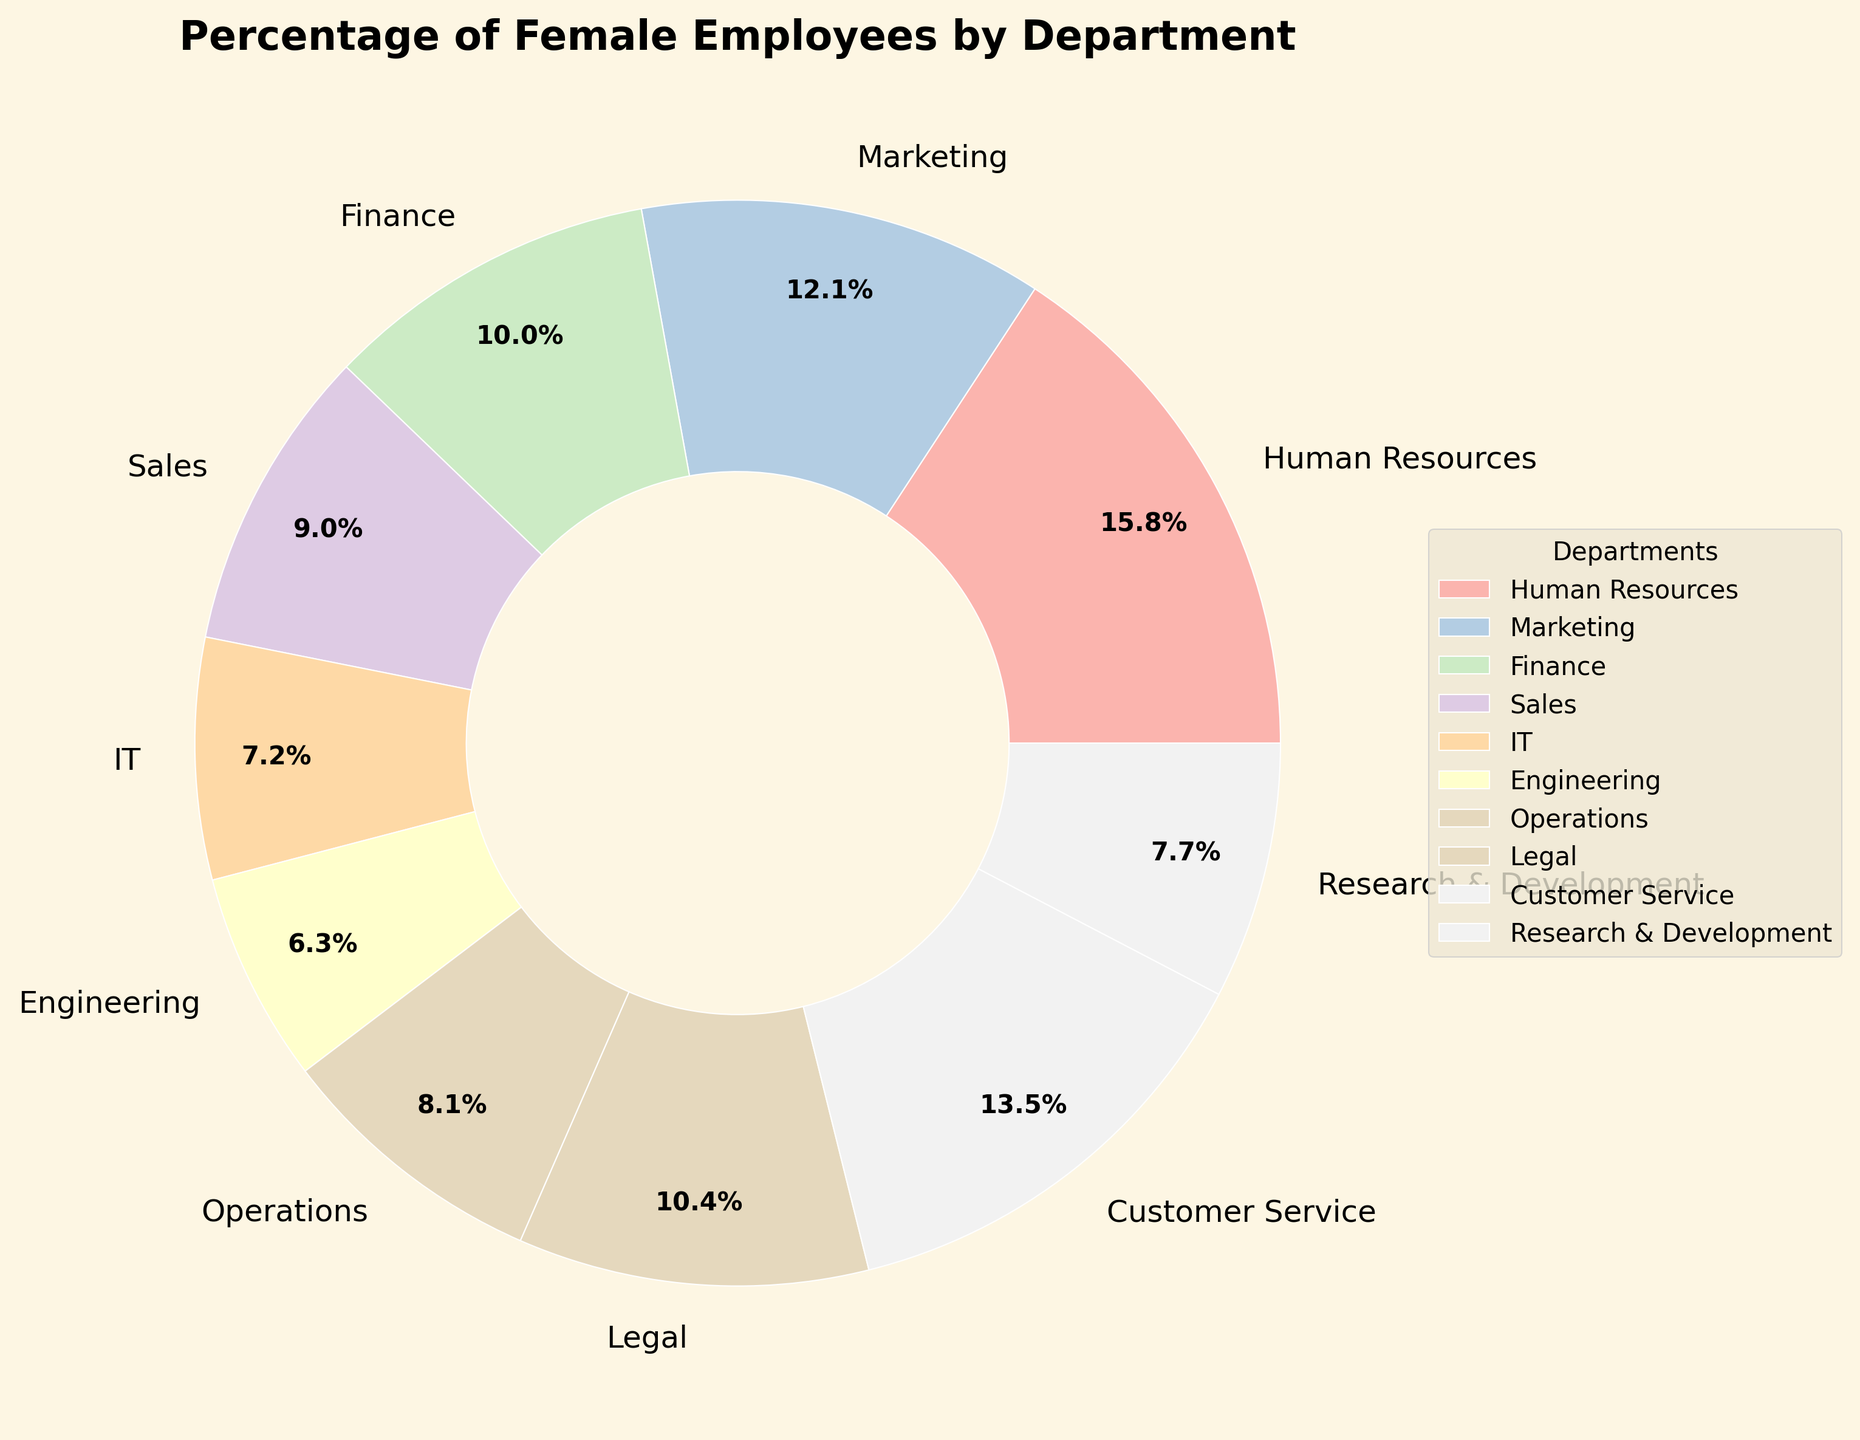Which department has the highest percentage of female employees? The department with the highest percentage of female employees is identified by finding the largest value on the pie chart.
Answer: Human Resources What is the combined percentage of female employees in IT and Sales? To find the combined percentage, sum the percentages of females in IT (31%) and Sales (39%). Therefore, 31% + 39% = 70%.
Answer: 70% How does the percentage of female employees in Marketing compare to that in Engineering? Compare the percentages directly: Marketing has 52% and Engineering has 27%. Marketing has a higher percentage than Engineering.
Answer: Marketing has a higher percentage What is the average percentage of female employees across all departments shown in the pie chart? Sum the percentages of females in all departments and divide by the number of departments: (68 + 52 + 43 + 39 + 31 + 27 + 35 + 45 + 58 + 33) / 10 = 43.1%
Answer: 43.1% Which department has approximately one-third of its employees as female? Find the department with a percentage close to 33%. Research & Development has 33% female employees, which is approximately one-third.
Answer: Research & Development Is the percentage of female employees in Legal higher than in Customer Service? Compare the percentages from the pie chart: Legal has 45% and Customer Service has 58%. Legal has a lower percentage.
Answer: No What is the difference in percentage of female employees between Human Resources and Operations? Subtract the percentage of Operations (35%) from Human Resources (68%): 68% - 35% = 33%.
Answer: 33% How many departments have a percentage of female employees greater than 40%? Count the departments with percentages greater than 40%: Human Resources (68%), Marketing (52%), Legal (45%), Customer Service (58%) - total 4 departments.
Answer: 4 Which department has the lowest percentage of female employees? Identify the department with the smallest slice in the pie chart. Engineering has the lowest percentage at 27%.
Answer: Engineering What is the ratio of female employees in Finance compared to IT? Divide the percentage of female employees in Finance by that in IT: 43% / 31% ≈ 1.39
Answer: 1.39 